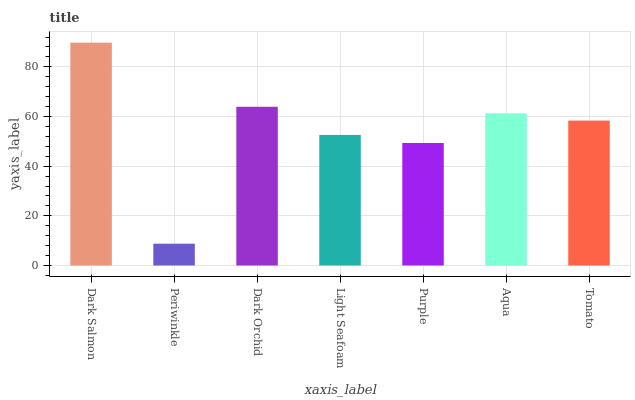Is Dark Orchid the minimum?
Answer yes or no. No. Is Dark Orchid the maximum?
Answer yes or no. No. Is Dark Orchid greater than Periwinkle?
Answer yes or no. Yes. Is Periwinkle less than Dark Orchid?
Answer yes or no. Yes. Is Periwinkle greater than Dark Orchid?
Answer yes or no. No. Is Dark Orchid less than Periwinkle?
Answer yes or no. No. Is Tomato the high median?
Answer yes or no. Yes. Is Tomato the low median?
Answer yes or no. Yes. Is Dark Orchid the high median?
Answer yes or no. No. Is Aqua the low median?
Answer yes or no. No. 